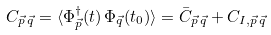Convert formula to latex. <formula><loc_0><loc_0><loc_500><loc_500>C _ { \vec { p } \, \vec { q } } = \langle \Phi ^ { \dagger } _ { \vec { p } } ( t ) \, \Phi _ { \vec { q } } ( t _ { 0 } ) \rangle = \bar { C } _ { \vec { p } \, \vec { q } } + C _ { I , \vec { p } \, \vec { q } }</formula> 